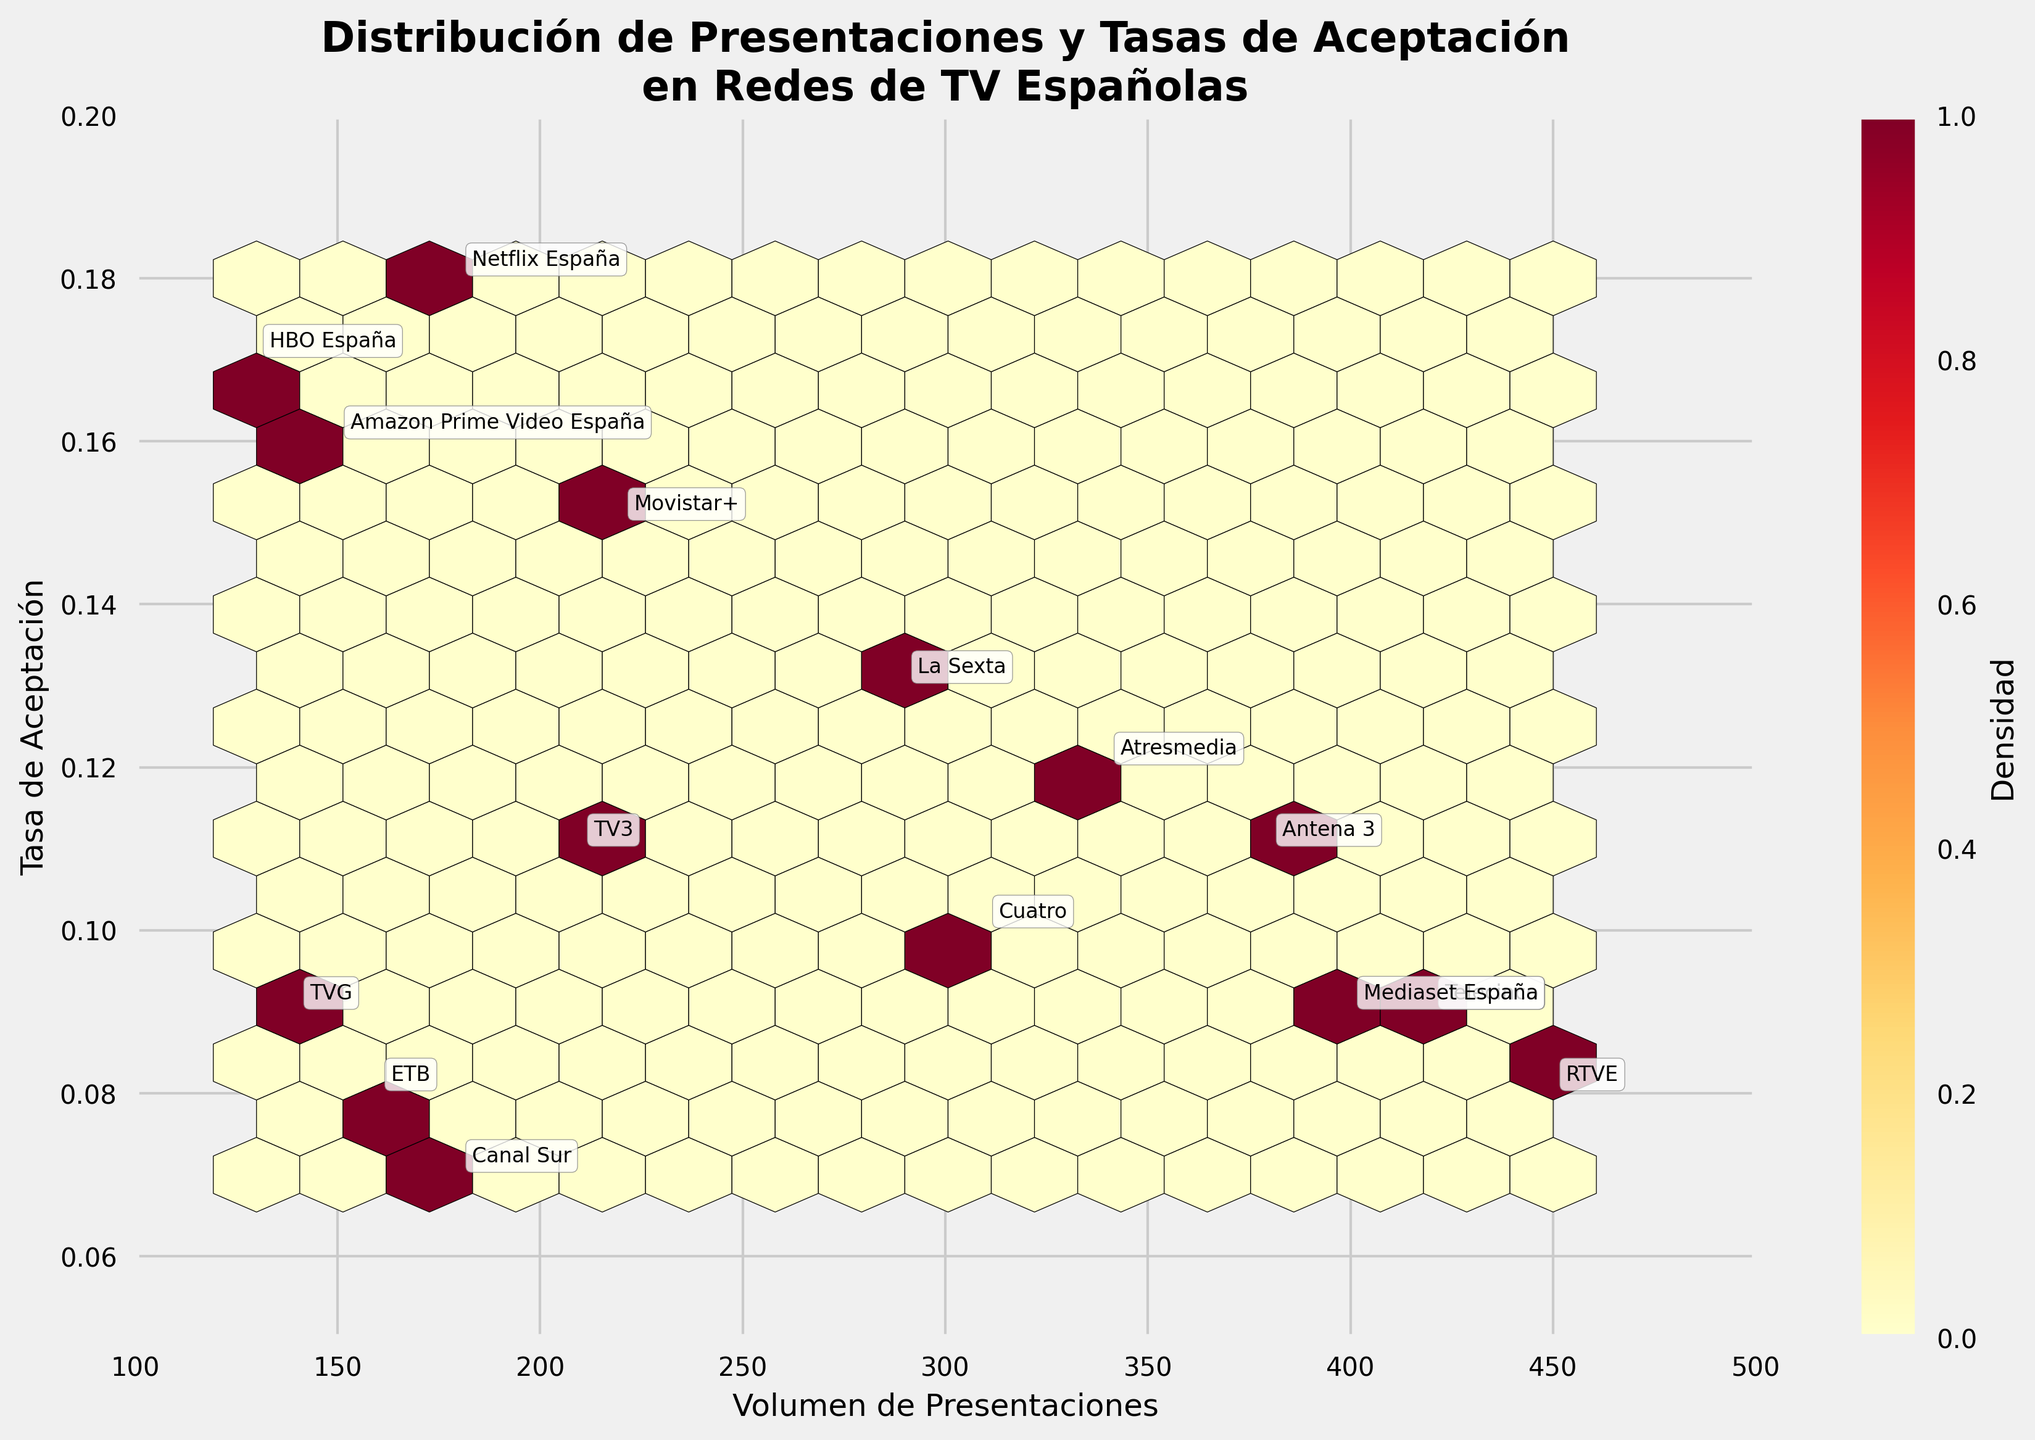What is the title of the hexbin plot? The title is usually placed at the top of the plot in a larger font size and bold style for easy identification. By looking at the top of the plot, you can read the title directly.
Answer: Distribución de Presentaciones y Tasas de Aceptación en Redes de TV Españolas What is the acceptance rate for RTVE? To find the acceptance rate for RTVE, look for the label 'RTVE' in the plot. Then, read its y-axis value.
Answer: 0.08 Which network has the highest acceptance rate? By identifying the highest point along the y-axis and then looking at the label closest to it, you can find which network it corresponds to.
Answer: Netflix España Which network has the lowest number of submissions and what is its acceptance rate? Locate the data point that is closest to the lower end of the x-axis and identify the corresponding label for that data point, then note the values for that network.
Answer: HBO España, 0.17 How many networks have an acceptance rate greater than 0.15? Inspect the y-axis and count all the data points that fall above 0.15, then identify the networks to count them.
Answer: Four (Movistar+, Netflix España, Amazon Prime Video España, HBO España) Which network has a higher acceptance rate, La Sexta or Cuatro? Compare the y-values for La Sexta and Cuatro to determine which is higher.
Answer: La Sexta How do submission volumes correlate with acceptance rates in this plot? By observing the overall pattern of the hexbin plot, one can determine if there is a positive, negative, or no correlation between the two variables.
Answer: No clear correlation Are there any densely populated areas in the plot? Refer to the color intensity and density as indicated by the color bar to identify areas where data points are more concentrated.
Answer: Yes, around 300 to 400 submissions and 0.08 to 0.12 acceptance rates What does the color bar in the plot represent? The color bar indicates the density of the data points. Darker or more intense colors show areas with higher data point density, while lighter colors show sparser regions.
Answer: Data point density 